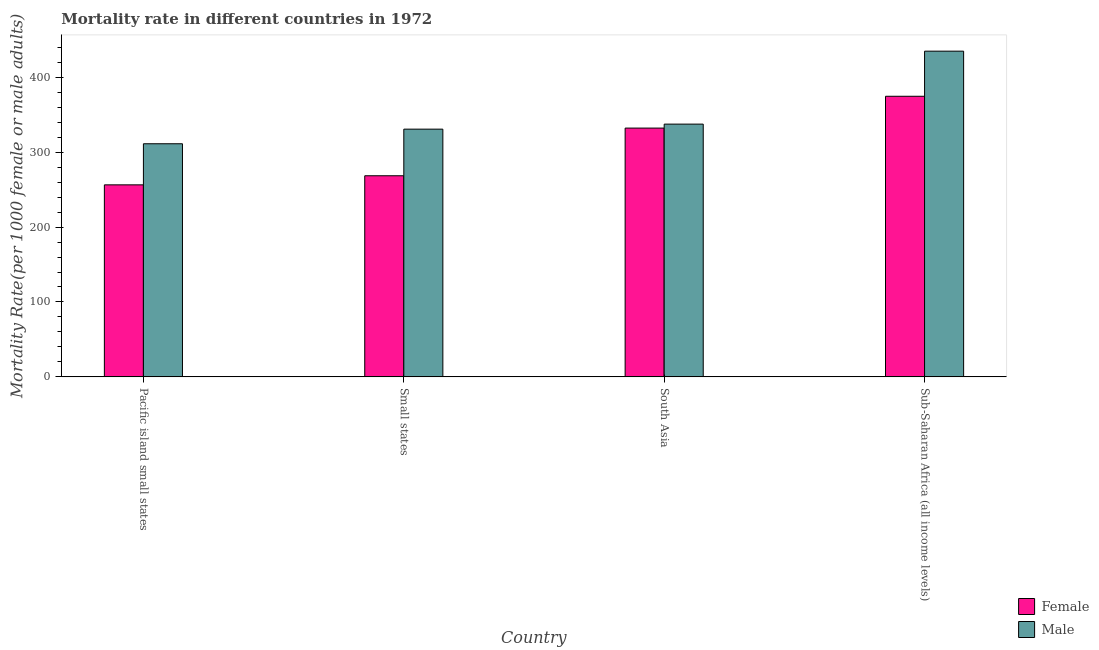How many groups of bars are there?
Offer a terse response. 4. Are the number of bars per tick equal to the number of legend labels?
Make the answer very short. Yes. What is the label of the 2nd group of bars from the left?
Make the answer very short. Small states. In how many cases, is the number of bars for a given country not equal to the number of legend labels?
Make the answer very short. 0. What is the male mortality rate in South Asia?
Ensure brevity in your answer.  337.48. Across all countries, what is the maximum male mortality rate?
Offer a very short reply. 434.88. Across all countries, what is the minimum male mortality rate?
Your response must be concise. 311.25. In which country was the male mortality rate maximum?
Your answer should be compact. Sub-Saharan Africa (all income levels). In which country was the male mortality rate minimum?
Provide a succinct answer. Pacific island small states. What is the total female mortality rate in the graph?
Provide a short and direct response. 1231.74. What is the difference between the male mortality rate in Pacific island small states and that in South Asia?
Keep it short and to the point. -26.22. What is the difference between the male mortality rate in Small states and the female mortality rate in Pacific island small states?
Offer a terse response. 74.37. What is the average male mortality rate per country?
Make the answer very short. 353.59. What is the difference between the female mortality rate and male mortality rate in South Asia?
Your response must be concise. -5.29. What is the ratio of the male mortality rate in South Asia to that in Sub-Saharan Africa (all income levels)?
Make the answer very short. 0.78. Is the male mortality rate in Pacific island small states less than that in Sub-Saharan Africa (all income levels)?
Your answer should be very brief. Yes. Is the difference between the male mortality rate in Pacific island small states and South Asia greater than the difference between the female mortality rate in Pacific island small states and South Asia?
Provide a short and direct response. Yes. What is the difference between the highest and the second highest female mortality rate?
Offer a terse response. 42.47. What is the difference between the highest and the lowest female mortality rate?
Your response must be concise. 118.27. In how many countries, is the female mortality rate greater than the average female mortality rate taken over all countries?
Make the answer very short. 2. What does the 2nd bar from the right in Small states represents?
Offer a very short reply. Female. How many bars are there?
Your answer should be compact. 8. Are all the bars in the graph horizontal?
Your response must be concise. No. How many countries are there in the graph?
Your answer should be very brief. 4. What is the difference between two consecutive major ticks on the Y-axis?
Give a very brief answer. 100. Are the values on the major ticks of Y-axis written in scientific E-notation?
Make the answer very short. No. Does the graph contain any zero values?
Make the answer very short. No. Does the graph contain grids?
Ensure brevity in your answer.  No. Where does the legend appear in the graph?
Your answer should be compact. Bottom right. What is the title of the graph?
Your answer should be very brief. Mortality rate in different countries in 1972. What is the label or title of the X-axis?
Give a very brief answer. Country. What is the label or title of the Y-axis?
Make the answer very short. Mortality Rate(per 1000 female or male adults). What is the Mortality Rate(per 1000 female or male adults) in Female in Pacific island small states?
Your answer should be very brief. 256.39. What is the Mortality Rate(per 1000 female or male adults) in Male in Pacific island small states?
Keep it short and to the point. 311.25. What is the Mortality Rate(per 1000 female or male adults) of Female in Small states?
Your response must be concise. 268.52. What is the Mortality Rate(per 1000 female or male adults) in Male in Small states?
Your answer should be compact. 330.76. What is the Mortality Rate(per 1000 female or male adults) of Female in South Asia?
Your response must be concise. 332.18. What is the Mortality Rate(per 1000 female or male adults) in Male in South Asia?
Keep it short and to the point. 337.48. What is the Mortality Rate(per 1000 female or male adults) in Female in Sub-Saharan Africa (all income levels)?
Your answer should be compact. 374.65. What is the Mortality Rate(per 1000 female or male adults) in Male in Sub-Saharan Africa (all income levels)?
Your answer should be very brief. 434.88. Across all countries, what is the maximum Mortality Rate(per 1000 female or male adults) of Female?
Your answer should be compact. 374.65. Across all countries, what is the maximum Mortality Rate(per 1000 female or male adults) in Male?
Your answer should be very brief. 434.88. Across all countries, what is the minimum Mortality Rate(per 1000 female or male adults) in Female?
Provide a succinct answer. 256.39. Across all countries, what is the minimum Mortality Rate(per 1000 female or male adults) of Male?
Provide a succinct answer. 311.25. What is the total Mortality Rate(per 1000 female or male adults) of Female in the graph?
Provide a short and direct response. 1231.74. What is the total Mortality Rate(per 1000 female or male adults) in Male in the graph?
Give a very brief answer. 1414.37. What is the difference between the Mortality Rate(per 1000 female or male adults) of Female in Pacific island small states and that in Small states?
Offer a very short reply. -12.13. What is the difference between the Mortality Rate(per 1000 female or male adults) in Male in Pacific island small states and that in Small states?
Your answer should be compact. -19.5. What is the difference between the Mortality Rate(per 1000 female or male adults) in Female in Pacific island small states and that in South Asia?
Provide a succinct answer. -75.79. What is the difference between the Mortality Rate(per 1000 female or male adults) of Male in Pacific island small states and that in South Asia?
Make the answer very short. -26.22. What is the difference between the Mortality Rate(per 1000 female or male adults) of Female in Pacific island small states and that in Sub-Saharan Africa (all income levels)?
Keep it short and to the point. -118.27. What is the difference between the Mortality Rate(per 1000 female or male adults) in Male in Pacific island small states and that in Sub-Saharan Africa (all income levels)?
Provide a short and direct response. -123.63. What is the difference between the Mortality Rate(per 1000 female or male adults) of Female in Small states and that in South Asia?
Keep it short and to the point. -63.67. What is the difference between the Mortality Rate(per 1000 female or male adults) in Male in Small states and that in South Asia?
Provide a succinct answer. -6.72. What is the difference between the Mortality Rate(per 1000 female or male adults) of Female in Small states and that in Sub-Saharan Africa (all income levels)?
Offer a terse response. -106.14. What is the difference between the Mortality Rate(per 1000 female or male adults) in Male in Small states and that in Sub-Saharan Africa (all income levels)?
Ensure brevity in your answer.  -104.13. What is the difference between the Mortality Rate(per 1000 female or male adults) in Female in South Asia and that in Sub-Saharan Africa (all income levels)?
Offer a terse response. -42.47. What is the difference between the Mortality Rate(per 1000 female or male adults) in Male in South Asia and that in Sub-Saharan Africa (all income levels)?
Keep it short and to the point. -97.41. What is the difference between the Mortality Rate(per 1000 female or male adults) in Female in Pacific island small states and the Mortality Rate(per 1000 female or male adults) in Male in Small states?
Keep it short and to the point. -74.37. What is the difference between the Mortality Rate(per 1000 female or male adults) of Female in Pacific island small states and the Mortality Rate(per 1000 female or male adults) of Male in South Asia?
Make the answer very short. -81.09. What is the difference between the Mortality Rate(per 1000 female or male adults) in Female in Pacific island small states and the Mortality Rate(per 1000 female or male adults) in Male in Sub-Saharan Africa (all income levels)?
Ensure brevity in your answer.  -178.49. What is the difference between the Mortality Rate(per 1000 female or male adults) in Female in Small states and the Mortality Rate(per 1000 female or male adults) in Male in South Asia?
Provide a succinct answer. -68.96. What is the difference between the Mortality Rate(per 1000 female or male adults) of Female in Small states and the Mortality Rate(per 1000 female or male adults) of Male in Sub-Saharan Africa (all income levels)?
Provide a short and direct response. -166.37. What is the difference between the Mortality Rate(per 1000 female or male adults) in Female in South Asia and the Mortality Rate(per 1000 female or male adults) in Male in Sub-Saharan Africa (all income levels)?
Give a very brief answer. -102.7. What is the average Mortality Rate(per 1000 female or male adults) in Female per country?
Ensure brevity in your answer.  307.94. What is the average Mortality Rate(per 1000 female or male adults) of Male per country?
Make the answer very short. 353.59. What is the difference between the Mortality Rate(per 1000 female or male adults) of Female and Mortality Rate(per 1000 female or male adults) of Male in Pacific island small states?
Offer a very short reply. -54.86. What is the difference between the Mortality Rate(per 1000 female or male adults) in Female and Mortality Rate(per 1000 female or male adults) in Male in Small states?
Give a very brief answer. -62.24. What is the difference between the Mortality Rate(per 1000 female or male adults) in Female and Mortality Rate(per 1000 female or male adults) in Male in South Asia?
Offer a terse response. -5.29. What is the difference between the Mortality Rate(per 1000 female or male adults) in Female and Mortality Rate(per 1000 female or male adults) in Male in Sub-Saharan Africa (all income levels)?
Offer a terse response. -60.23. What is the ratio of the Mortality Rate(per 1000 female or male adults) of Female in Pacific island small states to that in Small states?
Offer a terse response. 0.95. What is the ratio of the Mortality Rate(per 1000 female or male adults) of Male in Pacific island small states to that in Small states?
Provide a short and direct response. 0.94. What is the ratio of the Mortality Rate(per 1000 female or male adults) in Female in Pacific island small states to that in South Asia?
Your answer should be compact. 0.77. What is the ratio of the Mortality Rate(per 1000 female or male adults) in Male in Pacific island small states to that in South Asia?
Provide a succinct answer. 0.92. What is the ratio of the Mortality Rate(per 1000 female or male adults) in Female in Pacific island small states to that in Sub-Saharan Africa (all income levels)?
Ensure brevity in your answer.  0.68. What is the ratio of the Mortality Rate(per 1000 female or male adults) of Male in Pacific island small states to that in Sub-Saharan Africa (all income levels)?
Offer a terse response. 0.72. What is the ratio of the Mortality Rate(per 1000 female or male adults) in Female in Small states to that in South Asia?
Your response must be concise. 0.81. What is the ratio of the Mortality Rate(per 1000 female or male adults) of Male in Small states to that in South Asia?
Offer a terse response. 0.98. What is the ratio of the Mortality Rate(per 1000 female or male adults) of Female in Small states to that in Sub-Saharan Africa (all income levels)?
Provide a succinct answer. 0.72. What is the ratio of the Mortality Rate(per 1000 female or male adults) in Male in Small states to that in Sub-Saharan Africa (all income levels)?
Your answer should be compact. 0.76. What is the ratio of the Mortality Rate(per 1000 female or male adults) in Female in South Asia to that in Sub-Saharan Africa (all income levels)?
Provide a succinct answer. 0.89. What is the ratio of the Mortality Rate(per 1000 female or male adults) in Male in South Asia to that in Sub-Saharan Africa (all income levels)?
Your response must be concise. 0.78. What is the difference between the highest and the second highest Mortality Rate(per 1000 female or male adults) in Female?
Your response must be concise. 42.47. What is the difference between the highest and the second highest Mortality Rate(per 1000 female or male adults) in Male?
Provide a short and direct response. 97.41. What is the difference between the highest and the lowest Mortality Rate(per 1000 female or male adults) of Female?
Provide a succinct answer. 118.27. What is the difference between the highest and the lowest Mortality Rate(per 1000 female or male adults) in Male?
Make the answer very short. 123.63. 